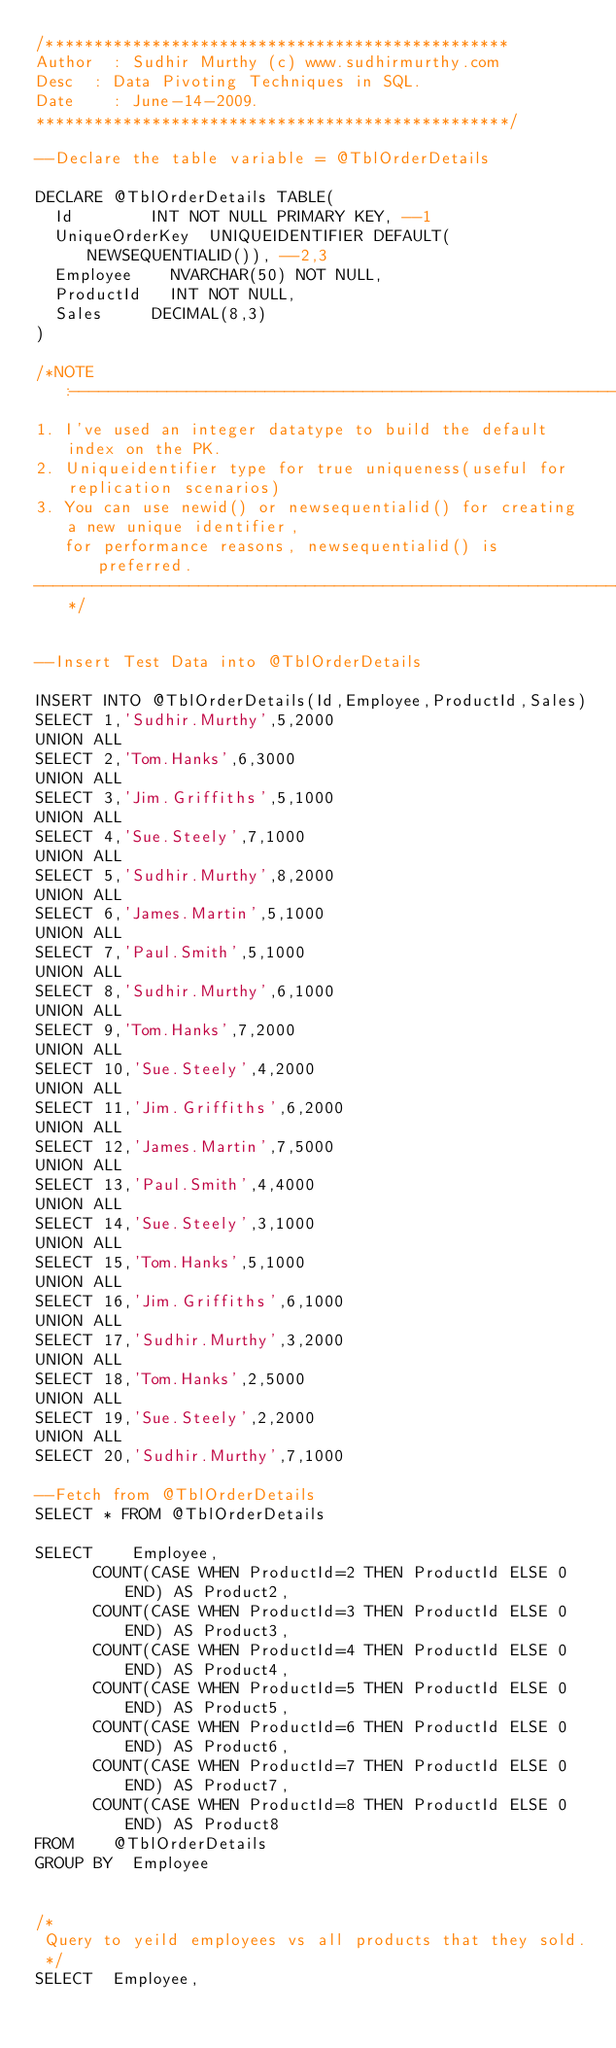<code> <loc_0><loc_0><loc_500><loc_500><_SQL_>/************************************************
Author	: Sudhir Murthy (c) www.sudhirmurthy.com
Desc	: Data Pivoting Techniques in SQL.
Date    : June-14-2009.
*************************************************/

--Declare the table variable = @TblOrderDetails

DECLARE @TblOrderDetails TABLE(
	Id				INT NOT NULL PRIMARY KEY, --1
	UniqueOrderKey	UNIQUEIDENTIFIER DEFAULT(NEWSEQUENTIALID()), --2,3
	Employee		NVARCHAR(50) NOT NULL,
	ProductId		INT NOT NULL,
	Sales			DECIMAL(8,3)		
)

/*NOTE:--------------------------------------------------------------------------
1. I've used an integer datatype to build the default index on the PK.
2. Uniqueidentifier type for true uniqueness(useful for replication scenarios)
3. You can use newid() or newsequentialid() for creating a new unique identifier,
   for performance reasons, newsequentialid() is preferred.
---------------------------------------------------------------------------------*/


--Insert Test Data into @TblOrderDetails

INSERT INTO @TblOrderDetails(Id,Employee,ProductId,Sales)
SELECT 1,'Sudhir.Murthy',5,2000
UNION ALL
SELECT 2,'Tom.Hanks',6,3000
UNION ALL
SELECT 3,'Jim.Griffiths',5,1000
UNION ALL
SELECT 4,'Sue.Steely',7,1000
UNION ALL
SELECT 5,'Sudhir.Murthy',8,2000
UNION ALL
SELECT 6,'James.Martin',5,1000
UNION ALL
SELECT 7,'Paul.Smith',5,1000
UNION ALL
SELECT 8,'Sudhir.Murthy',6,1000
UNION ALL
SELECT 9,'Tom.Hanks',7,2000
UNION ALL
SELECT 10,'Sue.Steely',4,2000
UNION ALL
SELECT 11,'Jim.Griffiths',6,2000
UNION ALL
SELECT 12,'James.Martin',7,5000
UNION ALL
SELECT 13,'Paul.Smith',4,4000
UNION ALL
SELECT 14,'Sue.Steely',3,1000
UNION ALL
SELECT 15,'Tom.Hanks',5,1000
UNION ALL
SELECT 16,'Jim.Griffiths',6,1000
UNION ALL
SELECT 17,'Sudhir.Murthy',3,2000
UNION ALL
SELECT 18,'Tom.Hanks',2,5000
UNION ALL
SELECT 19,'Sue.Steely',2,2000
UNION ALL
SELECT 20,'Sudhir.Murthy',7,1000

--Fetch from @TblOrderDetails
SELECT * FROM @TblOrderDetails

SELECT		Employee,
			COUNT(CASE WHEN ProductId=2 THEN ProductId ELSE 0 END) AS Product2,
			COUNT(CASE WHEN ProductId=3 THEN ProductId ELSE 0 END) AS Product3,
			COUNT(CASE WHEN ProductId=4 THEN ProductId ELSE 0 END) AS Product4,
			COUNT(CASE WHEN ProductId=5 THEN ProductId ELSE 0 END) AS Product5,
			COUNT(CASE WHEN ProductId=6 THEN ProductId ELSE 0 END) AS Product6,
			COUNT(CASE WHEN ProductId=7 THEN ProductId ELSE 0 END) AS Product7,
			COUNT(CASE WHEN ProductId=8 THEN ProductId ELSE 0 END) AS Product8  
FROM		@TblOrderDetails
GROUP BY	Employee


/*
 Query to yeild employees vs all products that they sold.
 */	
SELECT	Employee,</code> 